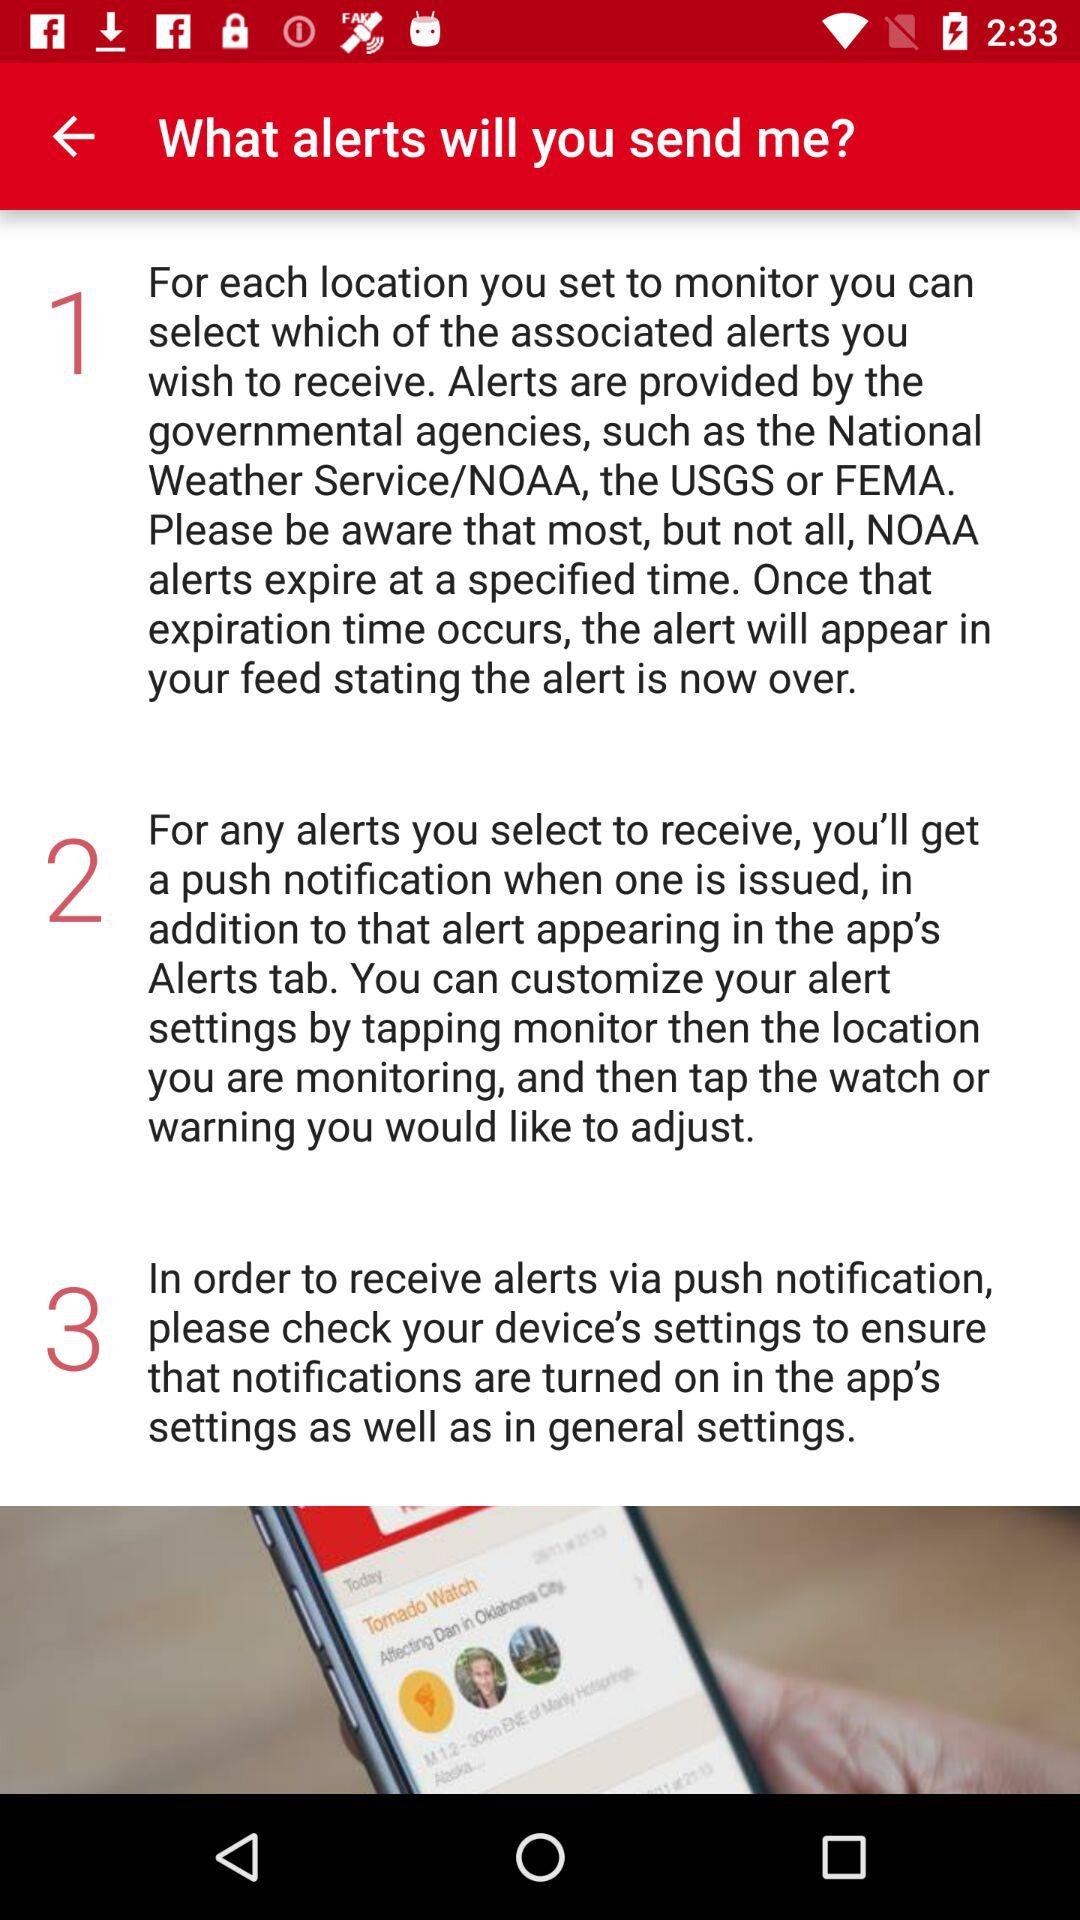How many steps are there in the process of customizing my alert settings?
Answer the question using a single word or phrase. 3 